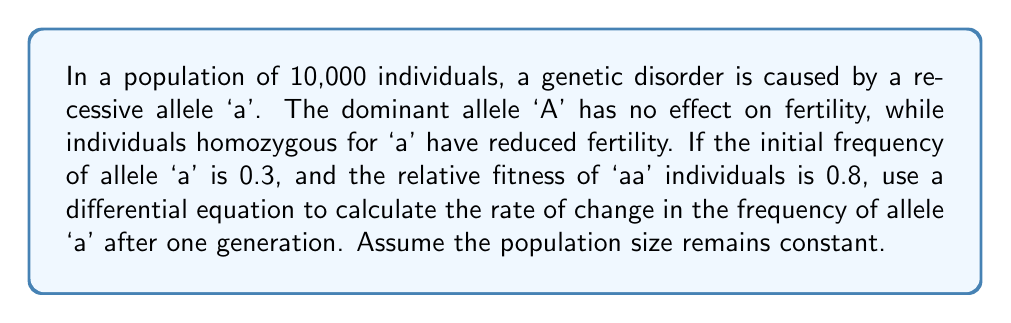Can you answer this question? To solve this problem, we'll use the differential equation for allele frequency change in a population with selection:

$$\frac{dp}{dt} = \frac{p(1-p)(p(w_{AA}-w_{Aa}) + (1-p)(w_{Aa}-w_{aa}))}{w}$$

Where:
$p$ = frequency of allele 'a'
$w_{AA}$, $w_{Aa}$, $w_{aa}$ = fitness of AA, Aa, and aa genotypes
$w$ = mean fitness of the population

Step 1: Determine the fitness values
$w_{AA} = w_{Aa} = 1$ (no effect on fertility)
$w_{aa} = 0.8$ (reduced fertility)

Step 2: Calculate the mean fitness ($w$)
$$w = p^2w_{aa} + 2p(1-p)w_{Aa} + (1-p)^2w_{AA}$$
$$w = (0.3)^2(0.8) + 2(0.3)(0.7)(1) + (0.7)^2(1) = 0.972$$

Step 3: Simplify the differential equation
Since $w_{AA} = w_{Aa}$, the equation simplifies to:
$$\frac{dp}{dt} = \frac{p(1-p)^2(1-w_{aa})}{w}$$

Step 4: Substitute values and calculate
$$\frac{dp}{dt} = \frac{0.3(1-0.3)^2(1-0.8)}{0.972}$$
$$\frac{dp}{dt} = \frac{0.3(0.7)^2(0.2)}{0.972} = 0.0302$$

This value represents the rate of change in the frequency of allele 'a' after one generation.
Answer: $\frac{dp}{dt} = 0.0302$ 